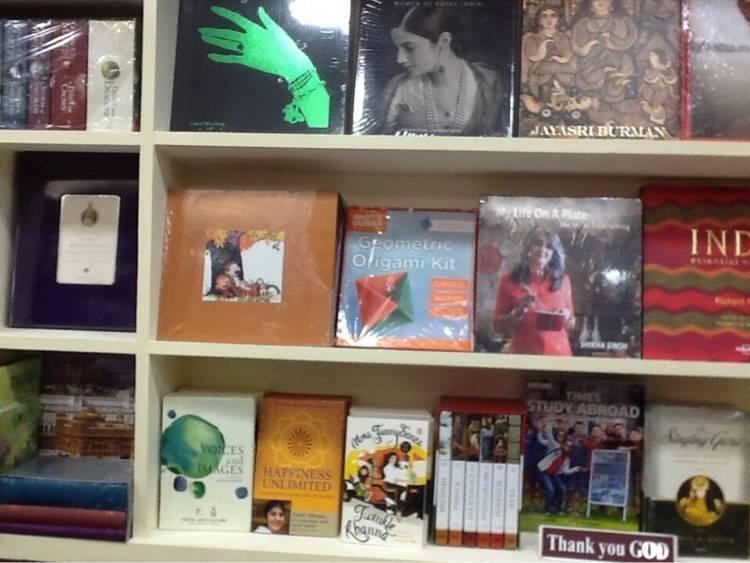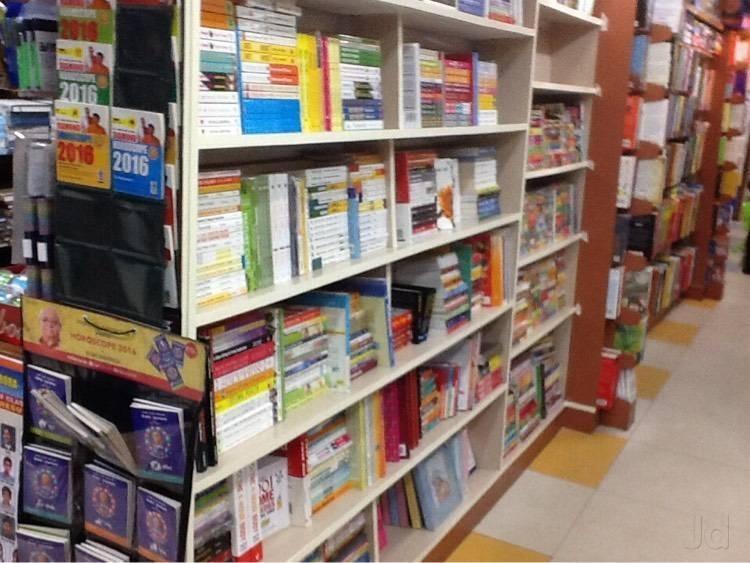The first image is the image on the left, the second image is the image on the right. Given the left and right images, does the statement "People are standing in a bookstore." hold true? Answer yes or no. No. The first image is the image on the left, the second image is the image on the right. Evaluate the accuracy of this statement regarding the images: "Exactly one person, a standing woman, can be seen inside of a shop lined with bookshelves.". Is it true? Answer yes or no. No. 